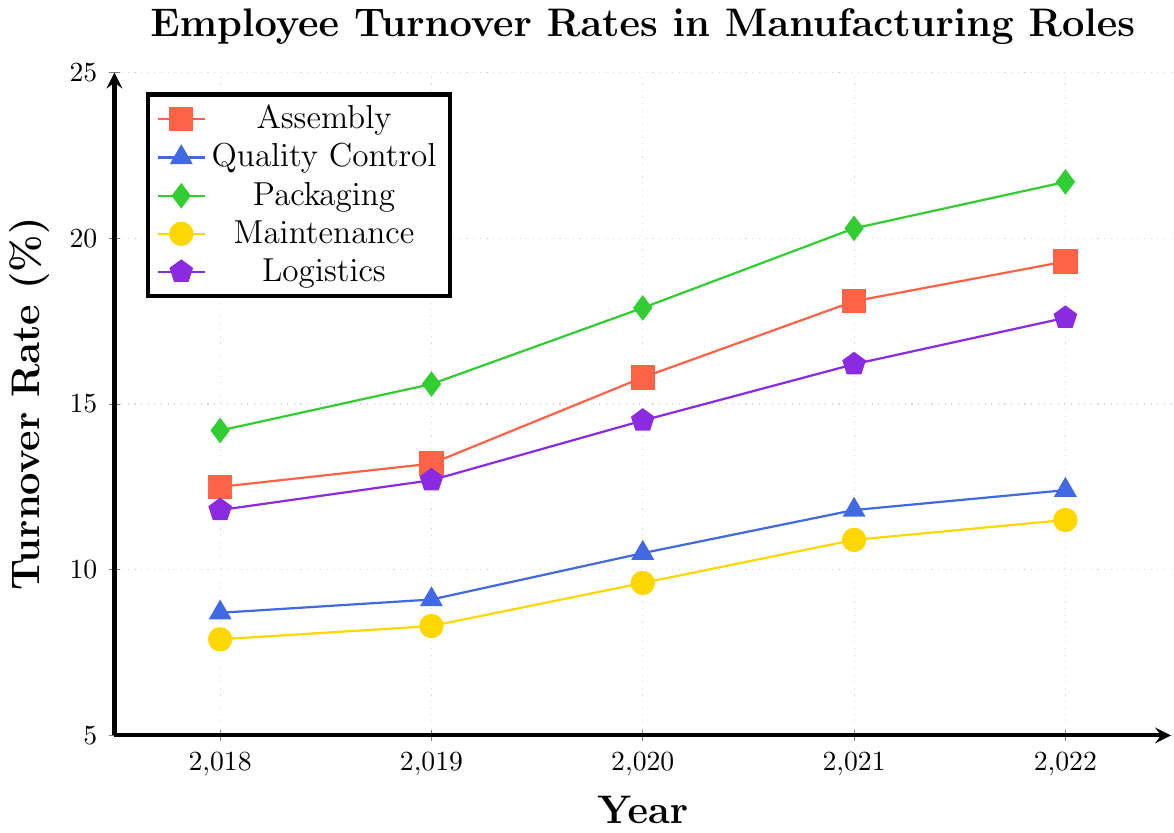Which department had the highest turnover rate in 2022? To find this, look at the highest point in 2022 across all the department lines. The Packaging department has the highest turnover rate in 2022, which reaches up to 21.7%.
Answer: Packaging How much did the turnover rate in the Assembly department increase from 2018 to 2022? To determine this, subtract the turnover rate of the Assembly department in 2018 from that in 2022. The turnover rate in 2022 is 19.3%, and in 2018 it was 12.5%. So, the increase is 19.3% - 12.5% = 6.8%.
Answer: 6.8% Which department has shown the most consistent year-over-year increase in turnover rates from 2018 to 2022? Examine the trend lines for each department. The Quality Control department shows a consistent, steady increase each year without any fluctuations.
Answer: Quality Control Compare the turnover rates of the Logistics and Maintenance departments in 2020. Which is higher and by how much? To compare, look at the turnover rates for both departments in 2020. Logistics has a rate of 14.5% and Maintenance has a rate of 9.6%. Thus, Logistics is higher by 14.5% - 9.6% = 4.9%.
Answer: Logistics, 4.9% Which department had the lowest turnover rate in 2019? Look for the lowest data point in 2019 across all the departments. The Maintenance department has the lowest turnover rate at 8.3%.
Answer: Maintenance Calculate the average turnover rate for the Packaging department over the five years from 2018 to 2022. Add the turnover rates from each year and divide by the number of years. (14.2% + 15.6% + 17.9% + 20.3% + 21.7%) / 5 = 89.7% / 5 = 17.94%.
Answer: 17.94% Between which consecutive years did the Assembly department experience the greatest increase in turnover rate? Calculate the yearly increase and find the maximum: 2019-2018: 13.2%-12.5%=0.7%, 2020-2019: 15.8%-13.2%=2.6%, 2021-2020: 18.1%-15.8%=2.3%, 2022-2021: 19.3%-18.1%=1.2%. The greatest increase occurred between 2019 and 2020.
Answer: 2019-2020 Of all five departments, which one had the lowest overall turnover rate in the year 2021? Look at the turnover rates for all departments in 2021 and identify the lowest one. The Maintenance department has the lowest turnover rate at 10.9%.
Answer: Maintenance 